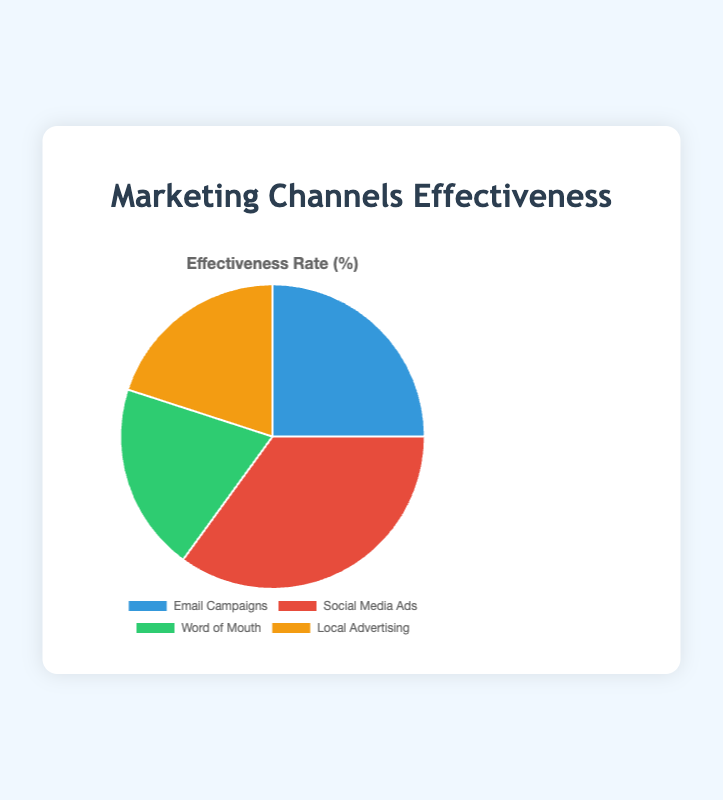What percentage of the total effectiveness does Word of Mouth and Local Advertising represent together? The effectiveness rates for Word of Mouth and Local Advertising are 20% each. Their combined effectiveness is 20% + 20% = 40%.
Answer: 40% Which marketing channel is the most effective? The effectiveness rates are: Email Campaigns (25%), Social Media Ads (35%), Word of Mouth (20%), and Local Advertising (20%). The highest rate is 35%, which corresponds to Social Media Ads.
Answer: Social Media Ads What is the difference in effectiveness between Social Media Ads and Email Campaigns? The effectiveness rates are 35% for Social Media Ads and 25% for Email Campaigns. The difference is 35% - 25% = 10%.
Answer: 10% Does any marketing channel have the same effectiveness rate? The effectiveness rates for Word of Mouth and Local Advertising are both 20%.
Answer: Yes What is the average effectiveness rate of all the marketing channels? The effectiveness rates are: Email Campaigns (25%), Social Media Ads (35%), Word of Mouth (20%), and Local Advertising (20%). The sum is 25% + 35% + 20% + 20% = 100%, and there are 4 channels. So, the average is 100% / 4 = 25%.
Answer: 25% Which marketing channel has the least effectiveness rate? The effectiveness rates are: Email Campaigns (25%), Social Media Ads (35%), Word of Mouth (20%), and Local Advertising (20%). The lowest rates are 20%, both for Word of Mouth and Local Advertising.
Answer: Word of Mouth and Local Advertising What is the combined effectiveness rate of Email Campaigns and Social Media Ads? The effectiveness rates for Email Campaigns and Social Media Ads are 25% and 35%, respectively. Their combined effectiveness is 25% + 35% = 60%.
Answer: 60% How much more effective are Social Media Ads compared to Word of Mouth? The effectiveness rates of Social Media Ads and Word of Mouth are 35% and 20%, respectively. The difference is 35% - 20% = 15%.
Answer: 15% Identify the color associated with Social Media Ads in the pie chart. Social Media Ads are represented by the color red in the pie chart.
Answer: Red 